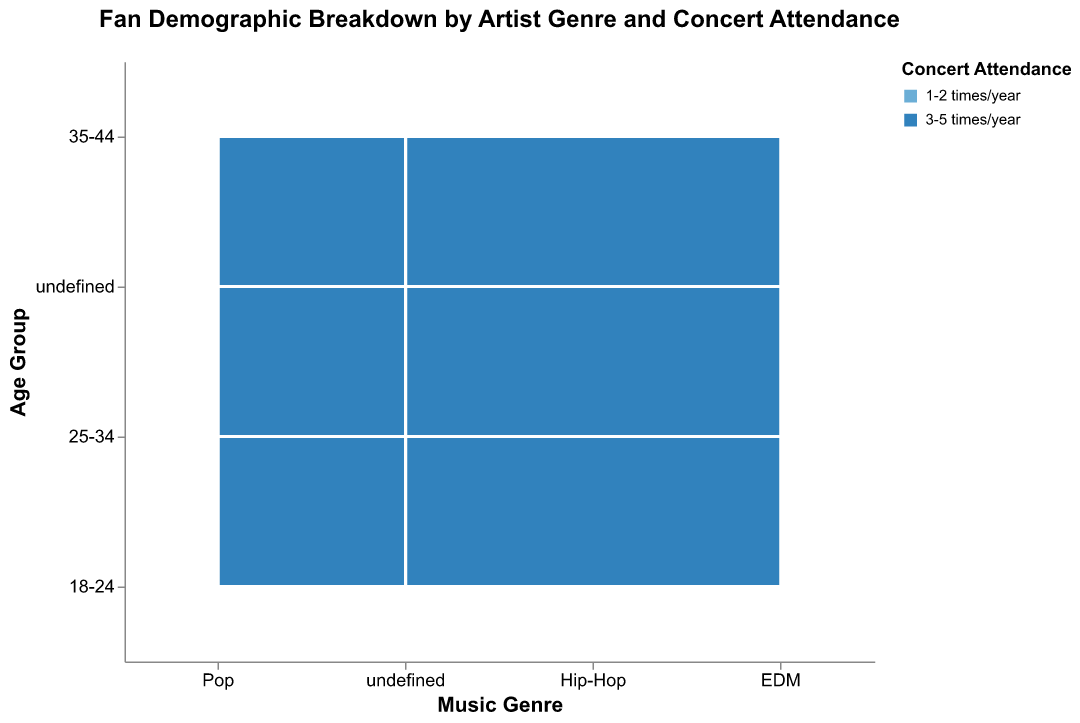What is the title of the figure? The title is located at the top of the figure and is written in a larger, bold font compared to other text elements.
Answer: Fan Demographic Breakdown by Artist Genre and Concert Attendance What colors represent each attendance frequency? The legend on the right side of the figure indicates that "1-2 times/year" is represented by a light blue color and "3-5 times/year" is represented by a darker blue color.
Answer: Light blue and dark blue Which age group has the highest concert attendance for EDM? To answer this, look at the size of the rectangles within the EDM genre column and compare them for each age group.
Answer: 18-24 For Hip-Hop, which age group has more frequent concert attendance, 25-34 or 35-44? Compare the sizes of the rectangles within the Hip-Hop column for the 25-34 and 35-44 age groups, focusing on the dark blue color (3-5 times/year).
Answer: 25-34 What percentage of Pop fans aged 25-34 attend concerts 1-2 times/year? Look at the tooltip or use the height of the light blue rectangle for Pop fans aged 25-34 divided by the total height for that age group within Pop.
Answer: 54.2% Which genre has the most balanced attendance frequency for the 18-24 age group? Check the rectangles' height ratio of light blue to dark blue within the 18-24 age group for each genre. Balanced means the height of the light blue and dark blue rectangles are relatively close.
Answer: EDM What age group has the lowest overall concert attendance for Pop? Compare the combined heights of the light blue and dark blue rectangles for all age groups within the Pop genre.
Answer: 35-44 How does the attendance frequency of Pop fans aged 18-24 compare to Hip-Hop fans of the same age group? Look at the heights of the rectangles for the "18-24" age group within Pop and Hip-Hop genres for both colors.
Answer: Pop has slightly higher attendance Which age group of EDM fans is more likely to attend concerts 3-5 times/year? Within the EDM genre, compare the size of the dark blue rectangles across the age groups.
Answer: 25-34 